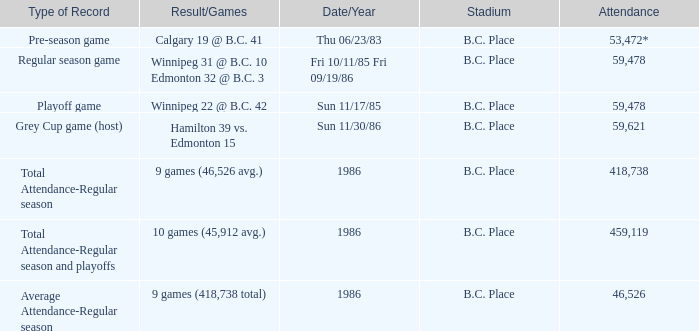What was the stadium that had the regular season game? B.C. Place. 